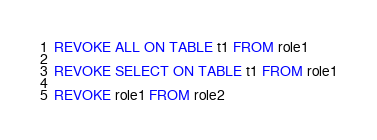<code> <loc_0><loc_0><loc_500><loc_500><_SQL_>REVOKE ALL ON TABLE t1 FROM role1

REVOKE SELECT ON TABLE t1 FROM role1

REVOKE role1 FROM role2
</code> 